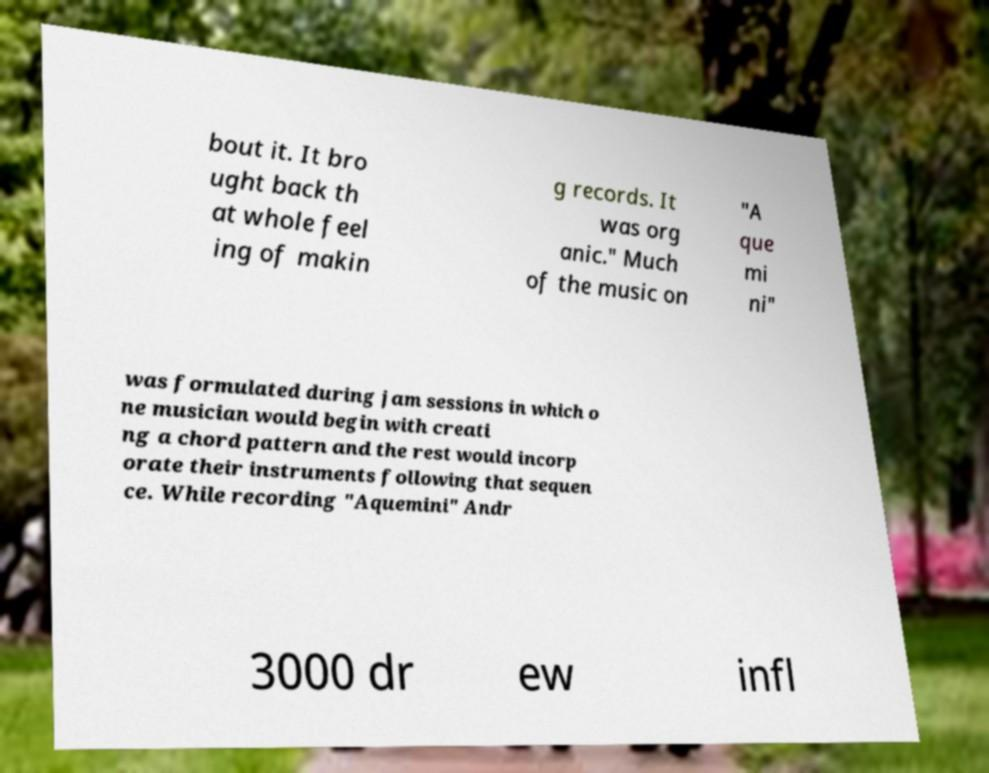Could you assist in decoding the text presented in this image and type it out clearly? bout it. It bro ught back th at whole feel ing of makin g records. It was org anic." Much of the music on "A que mi ni" was formulated during jam sessions in which o ne musician would begin with creati ng a chord pattern and the rest would incorp orate their instruments following that sequen ce. While recording "Aquemini" Andr 3000 dr ew infl 